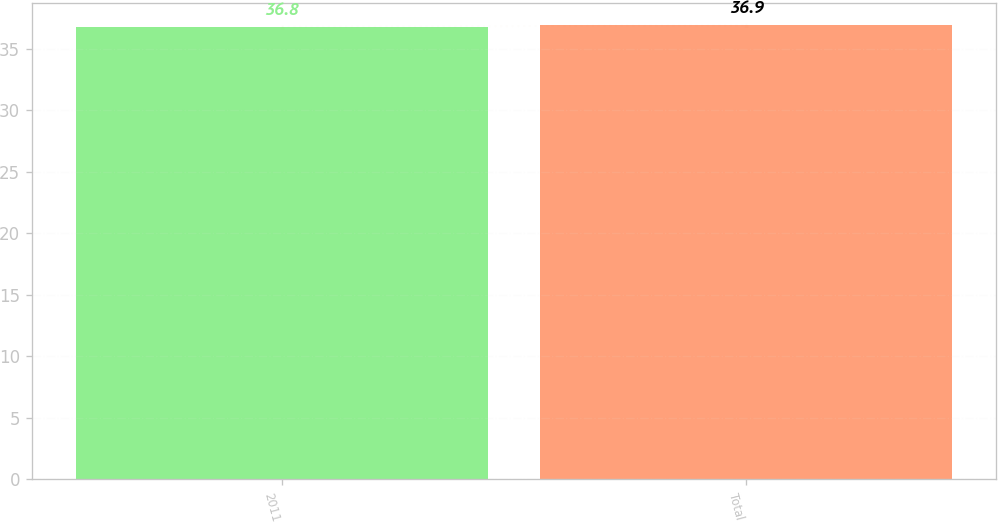Convert chart. <chart><loc_0><loc_0><loc_500><loc_500><bar_chart><fcel>2011<fcel>Total<nl><fcel>36.8<fcel>36.9<nl></chart> 